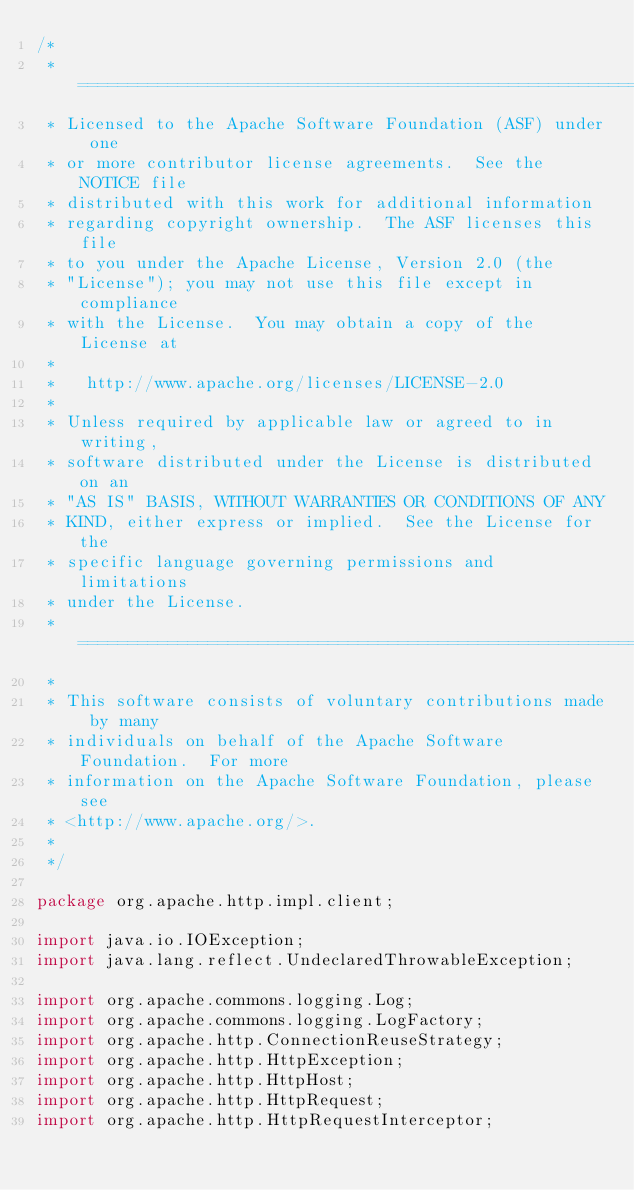<code> <loc_0><loc_0><loc_500><loc_500><_Java_>/*
 * ====================================================================
 * Licensed to the Apache Software Foundation (ASF) under one
 * or more contributor license agreements.  See the NOTICE file
 * distributed with this work for additional information
 * regarding copyright ownership.  The ASF licenses this file
 * to you under the Apache License, Version 2.0 (the
 * "License"); you may not use this file except in compliance
 * with the License.  You may obtain a copy of the License at
 *
 *   http://www.apache.org/licenses/LICENSE-2.0
 *
 * Unless required by applicable law or agreed to in writing,
 * software distributed under the License is distributed on an
 * "AS IS" BASIS, WITHOUT WARRANTIES OR CONDITIONS OF ANY
 * KIND, either express or implied.  See the License for the
 * specific language governing permissions and limitations
 * under the License.
 * ====================================================================
 *
 * This software consists of voluntary contributions made by many
 * individuals on behalf of the Apache Software Foundation.  For more
 * information on the Apache Software Foundation, please see
 * <http://www.apache.org/>.
 *
 */

package org.apache.http.impl.client;

import java.io.IOException;
import java.lang.reflect.UndeclaredThrowableException;

import org.apache.commons.logging.Log;
import org.apache.commons.logging.LogFactory;
import org.apache.http.ConnectionReuseStrategy;
import org.apache.http.HttpException;
import org.apache.http.HttpHost;
import org.apache.http.HttpRequest;
import org.apache.http.HttpRequestInterceptor;</code> 